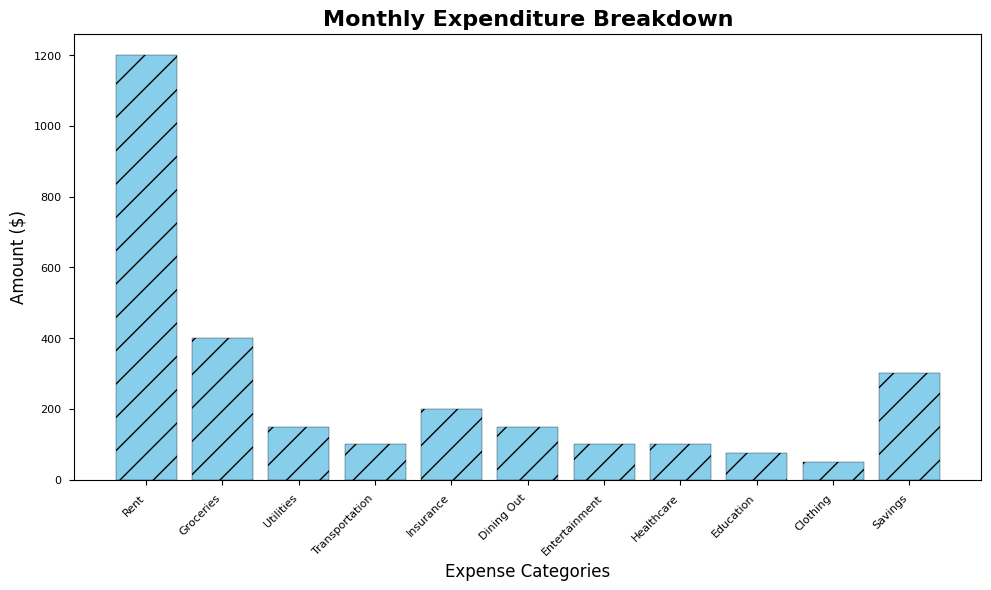Which category has the highest expenditure? The tallest bar in the chart represents the highest expenditure. It corresponds to "Rent" with an amount of $1200.
Answer: Rent What is the total expenditure on Transportation, Entertainment, and Healthcare combined? Sum the amounts for Transportation ($100), Entertainment ($100), and Healthcare ($100). The total is $100 + $100 + $100 = $300.
Answer: $300 Which two categories have the smallest expenditures? The shortest bars in the chart represent the smallest expenditures, which correspond to "Clothing" ($50) and "Education" ($75).
Answer: Clothing, Education How much more is spent on Rent compared to Groceries? Subtract the expenditure on Groceries ($400) from the expenditure on Rent ($1200). $1200 - $400 = $800.
Answer: $800 Are there any categories with the same expenditure amount? If so, which ones? Bars with the same height represent equal expenditures. Since Dining Out ($150) and Utilities ($150) have bars of the same height, they have the same expenditure.
Answer: Dining Out, Utilities What is the average expenditure across all categories? Add all expenditures and divide by the number of categories. ($1200 + $400 + $150 + $100 + $200 + $150 + $100 + $100 + $75 + $50 + $300) / 11 = $2825 / 11 = $256.82.
Answer: $256.82 Which category has the lowest expenditure and what is the amount? The shortest bar represents the category with the lowest expenditure, which is "Clothing" with an amount of $50.
Answer: Clothing, $50 What is the expenditure gap between Savings and Insurance? Subtract the expenditure on Insurance ($200) from the expenditure on Savings ($300). $300 - $200 = $100.
Answer: $100 What percentage of the total expenditure does Groceries represent? Calculate the total expenditure and then the percentage of Groceries. Total is $2825. Groceries amount is $400. ($400 / $2825) * 100 ≈ 14.16%.
Answer: 14.16% 